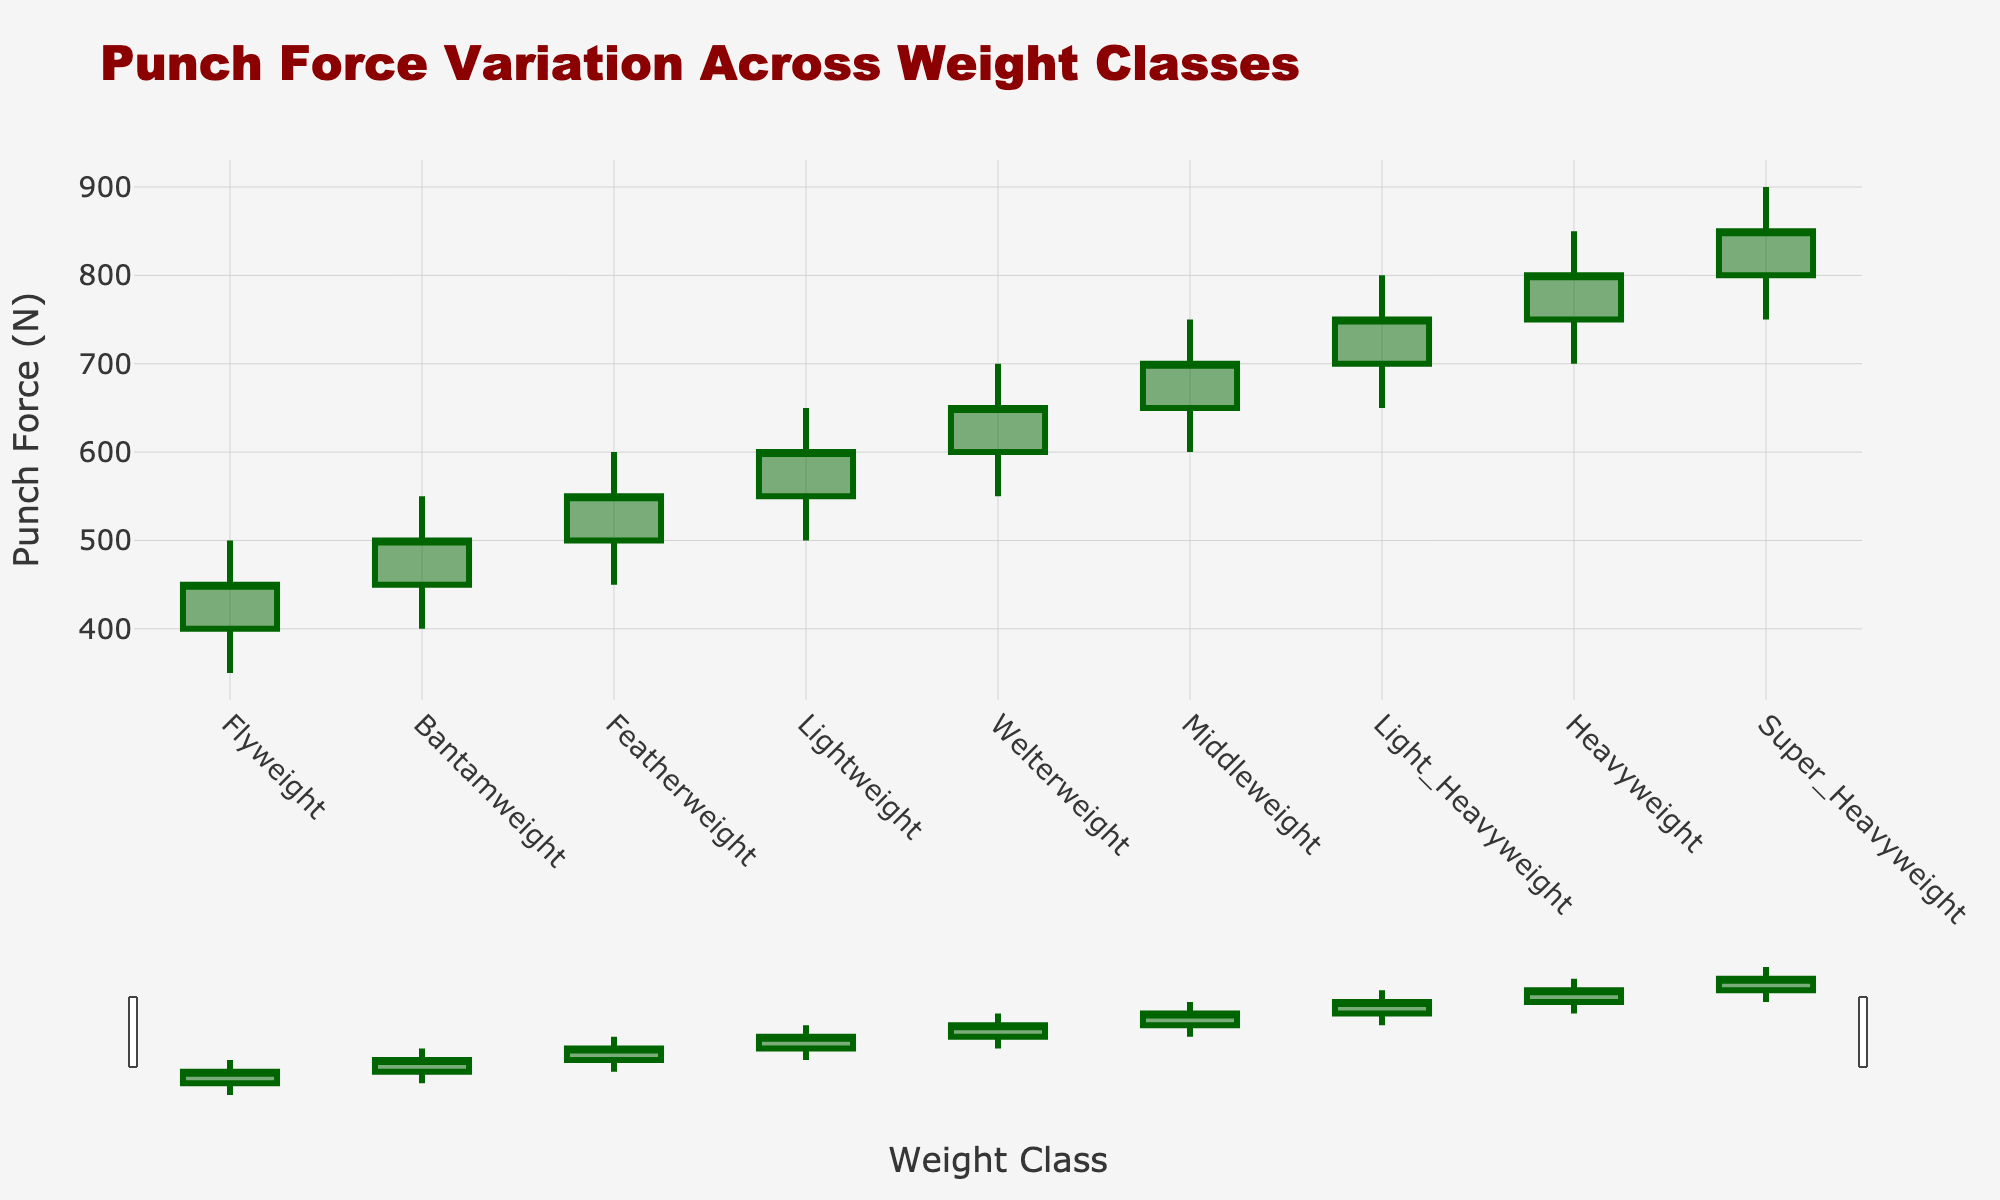What is the title of the figure? The title is generally placed at the top center or top left of the figure. Here, it reads "Punch Force Variation Across Weight Classes".
Answer: Punch Force Variation Across Weight Classes How many weight classes are shown in the figure? Each weight class is denoted by a candlestick, and there are nine weight classes listed in the data provided.
Answer: 9 What is the punch force range for the Heavyweight class? For the Heavyweight class, the punch force ranges from the lowest value at 700 N to the highest value at 850 N.
Answer: 700 to 850 N Which weight class has the highest punch force value and what is it? The highest punch force value is shown by the highest point on the candlestick for each weight class. The Super Heavyweight class has the highest value, which is 900 N.
Answer: Super Heavyweight, 900 N Compare the punch force ranges between the Flyweight and Middleweight classes. The Flyweight class ranges from 350 N to 500 N (a span of 150 N), whereas the Middleweight class ranges from 600 N to 750 N (a span of 150 N).
Answer: Both have a punch force span of 150 N What is the difference between the highest punch force of the Super Heavyweight and Flyweight classes? The highest punch force for Super Heavyweight is 900 N and for Flyweight it is 500 N, so the difference is 900 - 500 = 400 N.
Answer: 400 N What is the average punch force closing value across all weight classes? Sum the closing values (450 + 500 + 550 + 600 + 650 + 700 + 750 + 800 + 850) which equals 5350, then divide by the number of classes, 9. So, the average is 5350 / 9 ≈ 594.44 N.
Answer: 594.44 N Which weight class shows the highest variability in punch force? Measure variability by the range, which is the difference between the high and low values. Super Heavyweight class ranges from 750 N to 900 N, a span of 150 N, which is standard across all classes shown.
Answer: All classes show a span of 150 N In which weight class does the punch force start and end at the same value? The punch force starts (open) and ends (close) at the same value in no given weight classes from the data provided.
Answer: None 